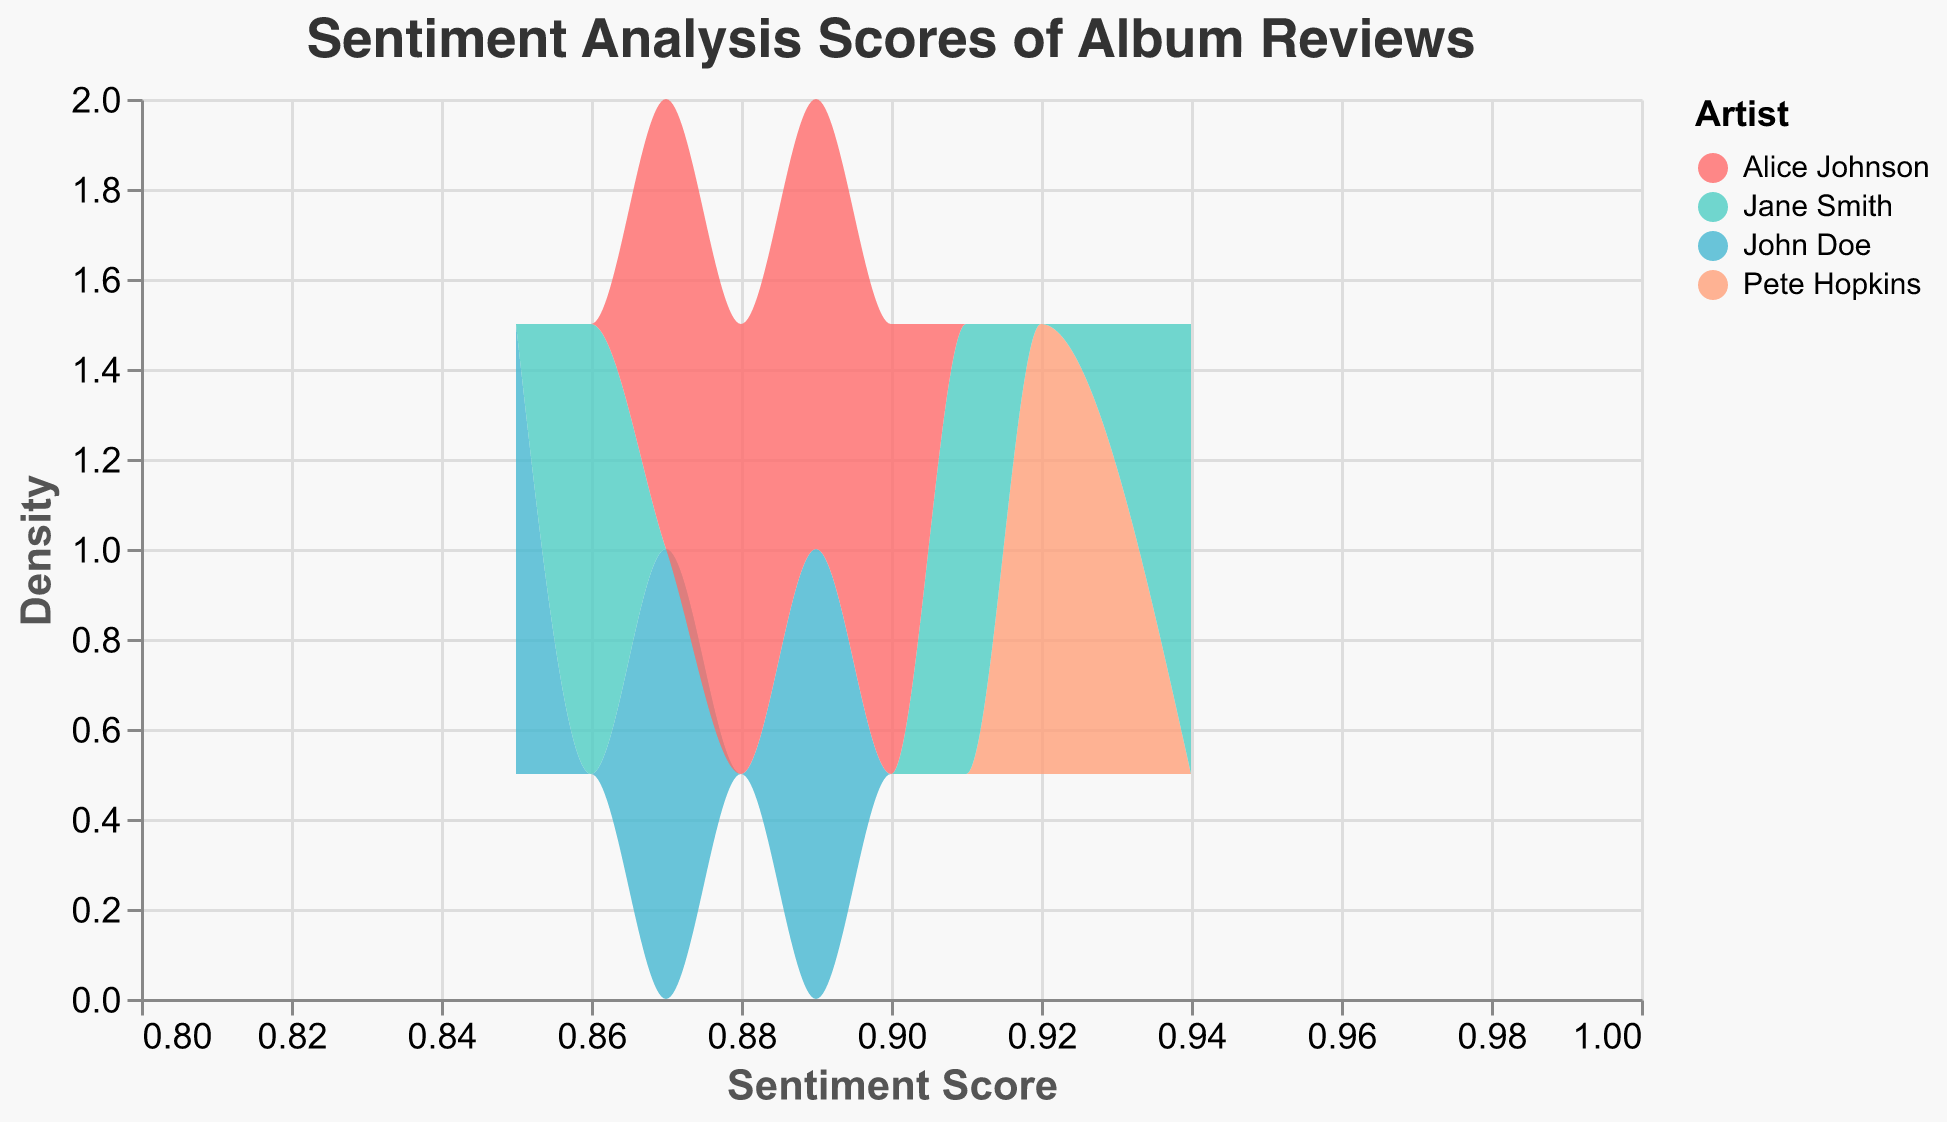What is the title of the plot? The plot title is typically displayed at the top of the figure and provides a summary of the visual information.
Answer: Sentiment Analysis Scores of Album Reviews What are the colors used to represent each artist on the plot? Each artist is represented by a unique color as indicated in the plot legend on the right side of the figure. The colors used are coral red for Pete Hopkins, light green for John Doe, light blue for Jane Smith, and light salmon for Alice Johnson.
Answer: Pete Hopkins: coral red, John Doe: light green, Jane Smith: light blue, Alice Johnson: light salmon Which artist has the highest sentiment score? By referring to the x-axis which shows the sentiment scores and identifying the peak of each artist's curve, we can determine which artist reaches the highest score. Jane Smith's curve extends to 0.94, which is the highest sentiment score.
Answer: Jane Smith How does Pete Hopkins' sentiment score distribution compare to John Doe's? Comparing the areas under the curves for Pete Hopkins and John Doe involves examining the positioning and spread of their respective curves on the x-axis. Pete Hopkins' sentiment score distribution is more centered around higher scores (closer to the 0.92 range), while John Doe's is distributed more towards lower scores ranging from 0.85 to 0.89.
Answer: Pete Hopkins' distribution is centered around higher scores Which artist has the largest spread in sentiment scores? The spread in sentiment scores is determined by observing the width of the area under the curve for each artist. Jane Smith shows a spread from approximately 0.86 to 0.94, indicating a larger range compared to the others.
Answer: Jane Smith What sentiment score has the highest density for Alice Johnson? The highest density for Alice Johnson can be identified by locating the peak of her curve. Alice Johnson's highest density occurs around the sentiment score of 0.88.
Answer: 0.88 How many artists have a sentiment score peak at 0.88? By examining the peaks of each artist's density plot on the x-axis at the sentiment score of 0.88, we count how many artists have a maximum density there. Alice Johnson and John Doe have peaks around 0.88.
Answer: Two artists How do the sentiment scores of Pete Hopkins' "Dreamscape" compare to Alice Johnson's albums? Comparing the sentiment scores involves noting the peaks and spread of the curves representing Pete Hopkins and Alice Johnson. Pete Hopkins' "Dreamscape" maintains a relatively high sentiment score at 0.92, while Alice Johnson's albums vary between 0.87 and 0.90, with a peak at 0.88.
Answer: Pete Hopkins' "Dreamscape" has higher sentiment scores on average What is the general trend of sentiment scores for all artists? Observing the general trend involves analyzing the central tendency and spread of the curves on the plot. Most artists have sentiment scores ranging from 0.85 to 0.94, with many peaks between 0.87 and 0.92, indicating most albums have moderately high sentiment ratings.
Answer: Scores generally range from 0.85 to 0.94 with peaks between 0.87 and 0.92 Who has a more concentrated sentiment score distribution, John Doe or Jane Smith? Concentration is determined by the narrowness and height of the curve. Jane Smith's distribution shows a higher concentration with a sharp peak, meaning her sentiment scores are clustered around specific values. John Doe's curve is flatter, indicating a broader distribution.
Answer: Jane Smith 